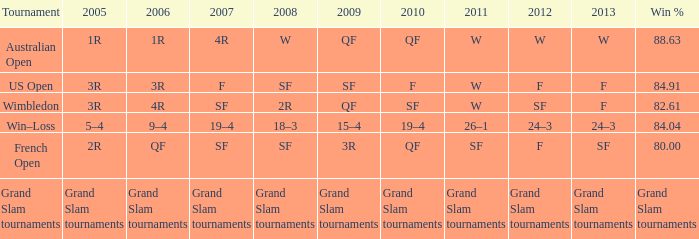Would you be able to parse every entry in this table? {'header': ['Tournament', '2005', '2006', '2007', '2008', '2009', '2010', '2011', '2012', '2013', 'Win %'], 'rows': [['Australian Open', '1R', '1R', '4R', 'W', 'QF', 'QF', 'W', 'W', 'W', '88.63'], ['US Open', '3R', '3R', 'F', 'SF', 'SF', 'F', 'W', 'F', 'F', '84.91'], ['Wimbledon', '3R', '4R', 'SF', '2R', 'QF', 'SF', 'W', 'SF', 'F', '82.61'], ['Win–Loss', '5–4', '9–4', '19–4', '18–3', '15–4', '19–4', '26–1', '24–3', '24–3', '84.04'], ['French Open', '2R', 'QF', 'SF', 'SF', '3R', 'QF', 'SF', 'F', 'SF', '80.00'], ['Grand Slam tournaments', 'Grand Slam tournaments', 'Grand Slam tournaments', 'Grand Slam tournaments', 'Grand Slam tournaments', 'Grand Slam tournaments', 'Grand Slam tournaments', 'Grand Slam tournaments', 'Grand Slam tournaments', 'Grand Slam tournaments', 'Grand Slam tournaments']]} WHat in 2005 has a Win % of 82.61? 3R. 